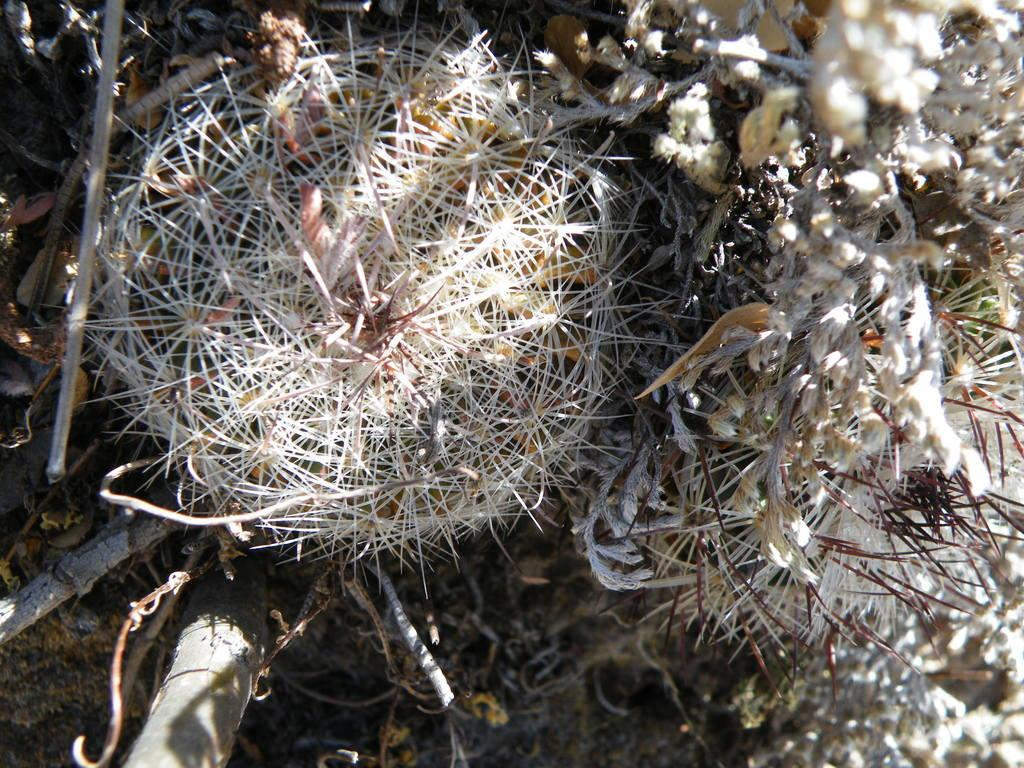What type of plant is present in the image? There is a dried flower in the image. What other objects can be seen in the image? There are dried sticks in the image. What type of creature is interacting with the dried flower in the image? There is no creature present in the image; it only features a dried flower and dried sticks. What wish can be granted by the dried flower in the image? There is no magical power associated with the dried flower in the image; it is simply a dried plant. 